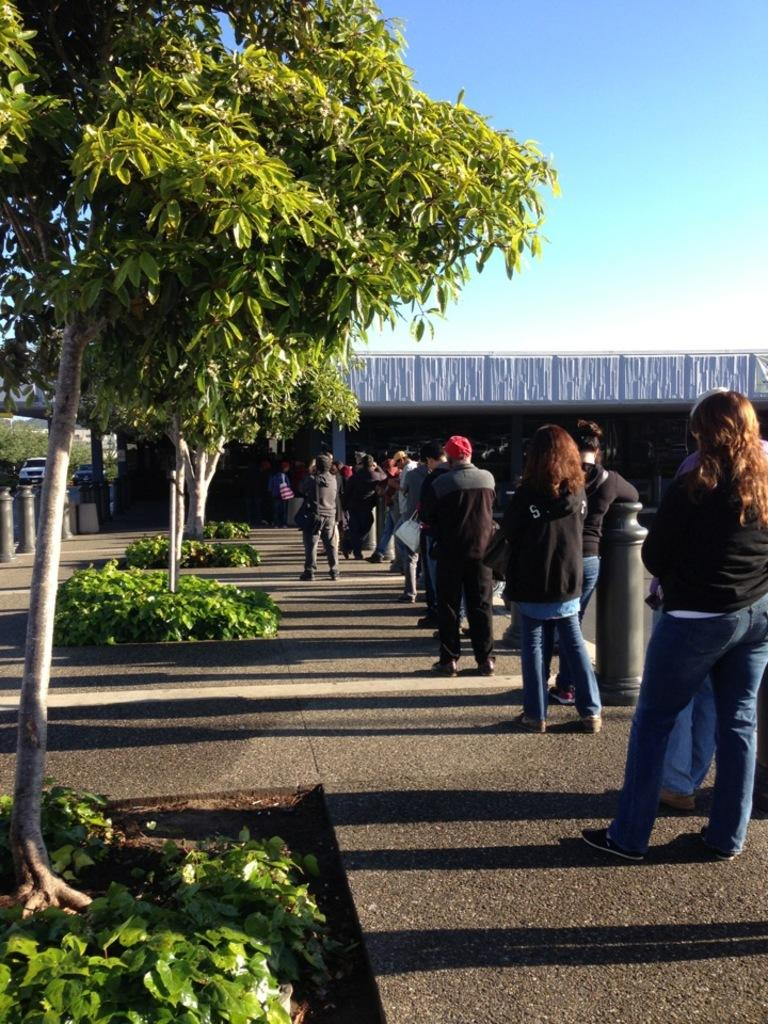What type of natural elements can be seen in the image? There are trees in the image. What type of man-made structure is visible in the image? There is a building in the image. How many people are present in the image? There are two people in the image. What is visible at the top of the image? The sky is visible at the top of the image. Can you tell me how many snails are crawling on the building in the image? There are no snails present in the image; it features trees, a building, and two people. What type of sink is visible in the image? There is no sink present in the image. 